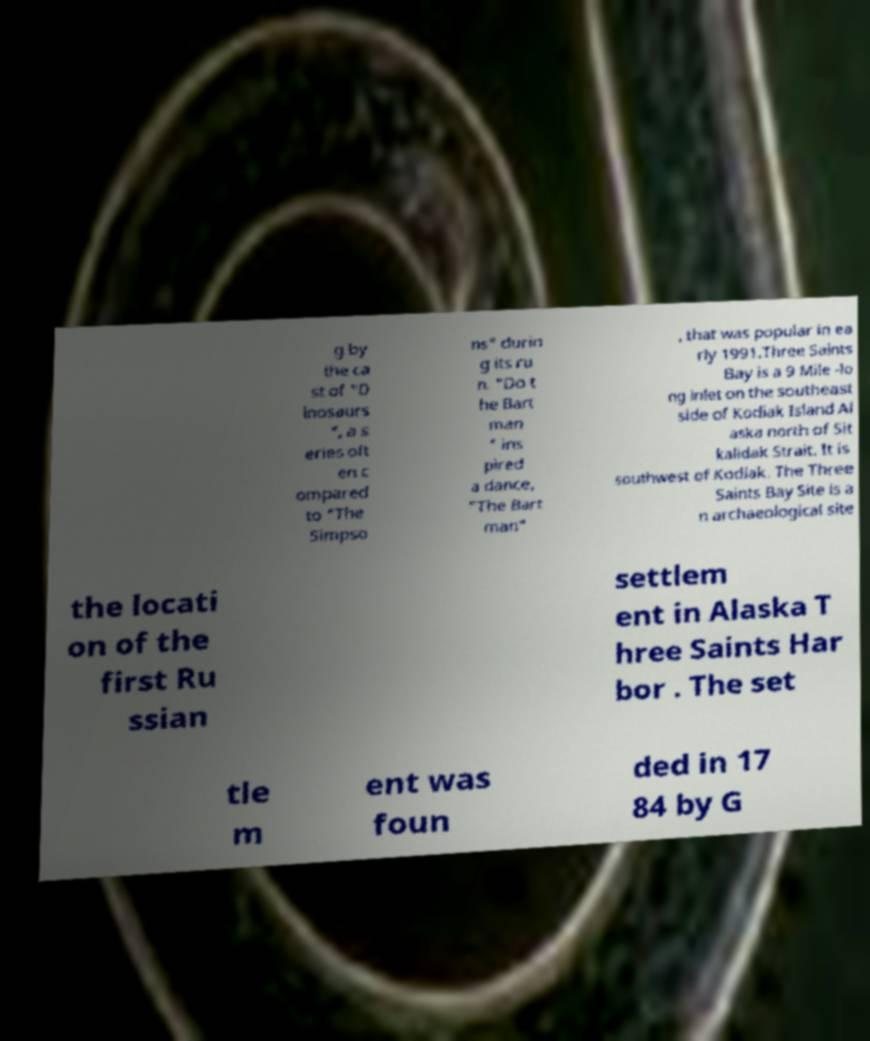Could you extract and type out the text from this image? g by the ca st of "D inosaurs ", a s eries oft en c ompared to "The Simpso ns" durin g its ru n. "Do t he Bart man " ins pired a dance, "The Bart man" , that was popular in ea rly 1991.Three Saints Bay is a 9 Mile -lo ng inlet on the southeast side of Kodiak Island Al aska north of Sit kalidak Strait. It is southwest of Kodiak. The Three Saints Bay Site is a n archaeological site the locati on of the first Ru ssian settlem ent in Alaska T hree Saints Har bor . The set tle m ent was foun ded in 17 84 by G 